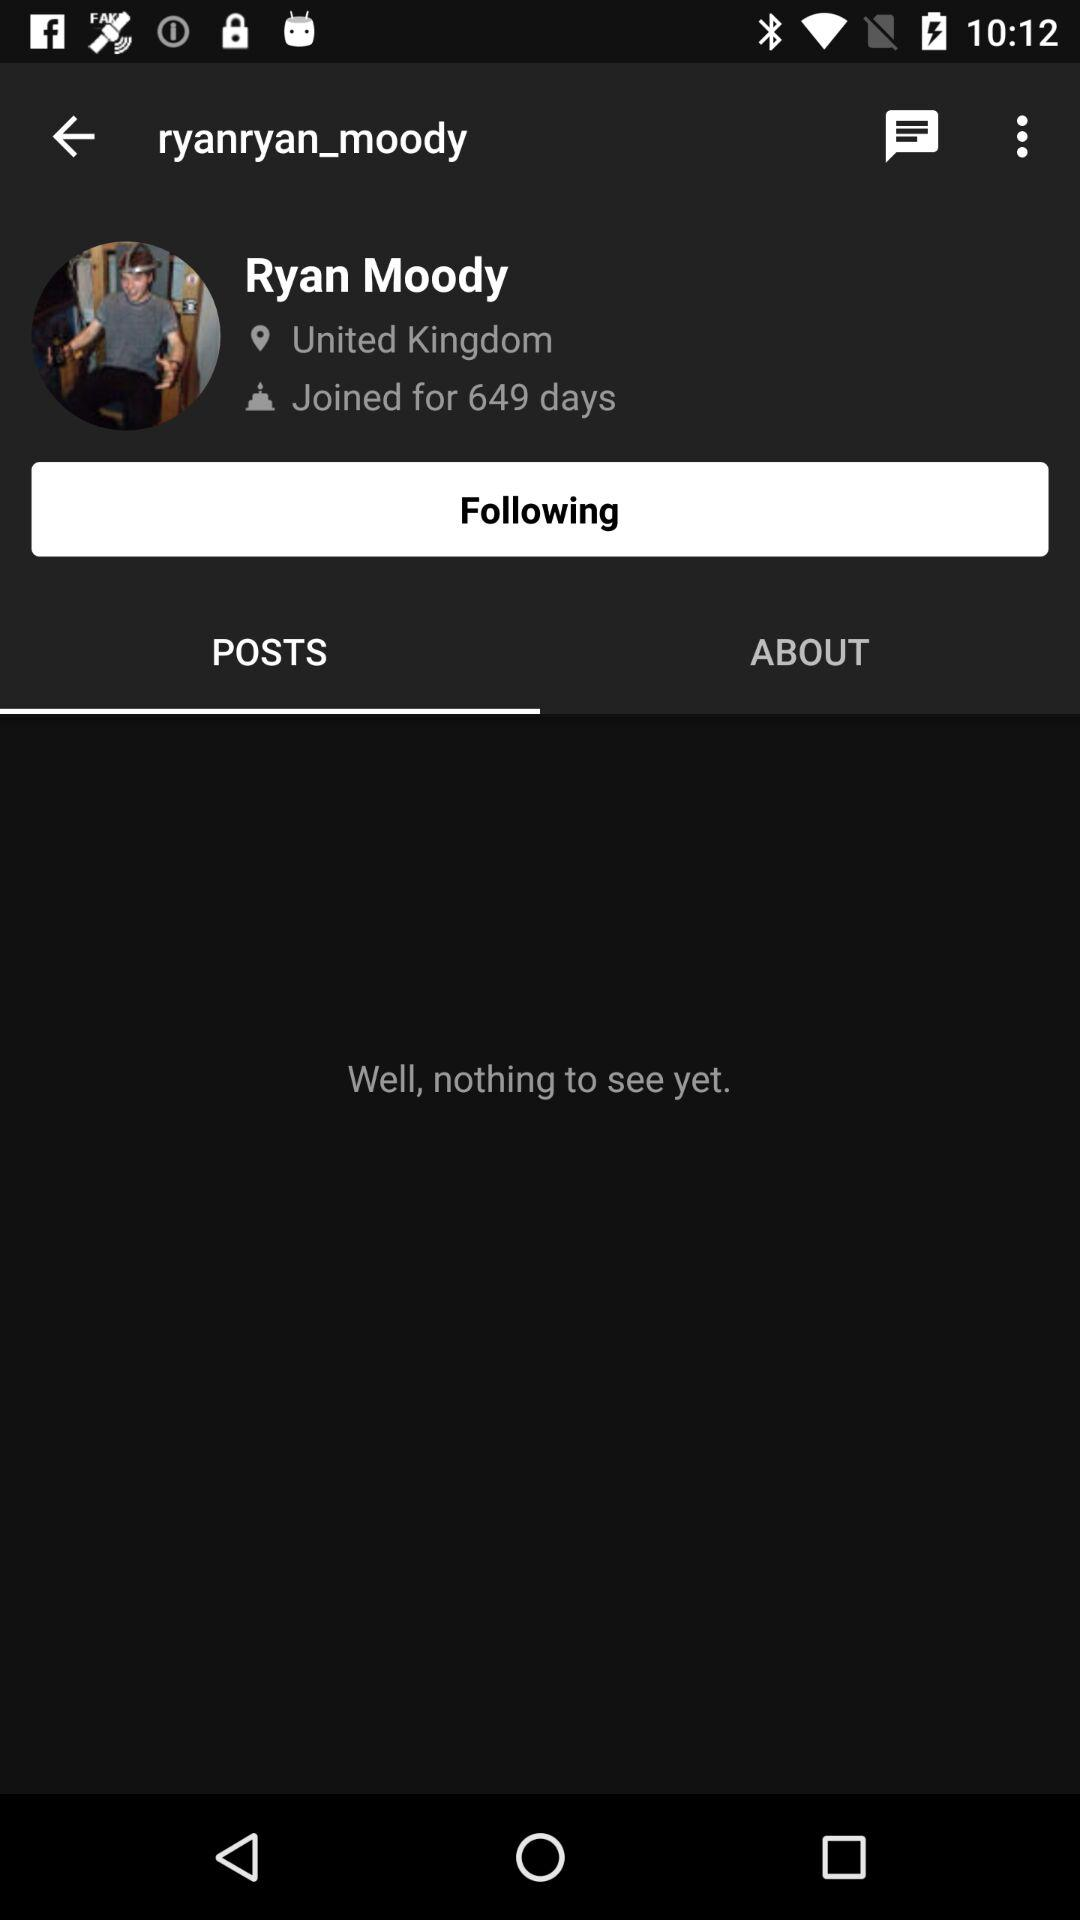How many days have passed since Ryan Moody joined the platform?
Answer the question using a single word or phrase. 649 